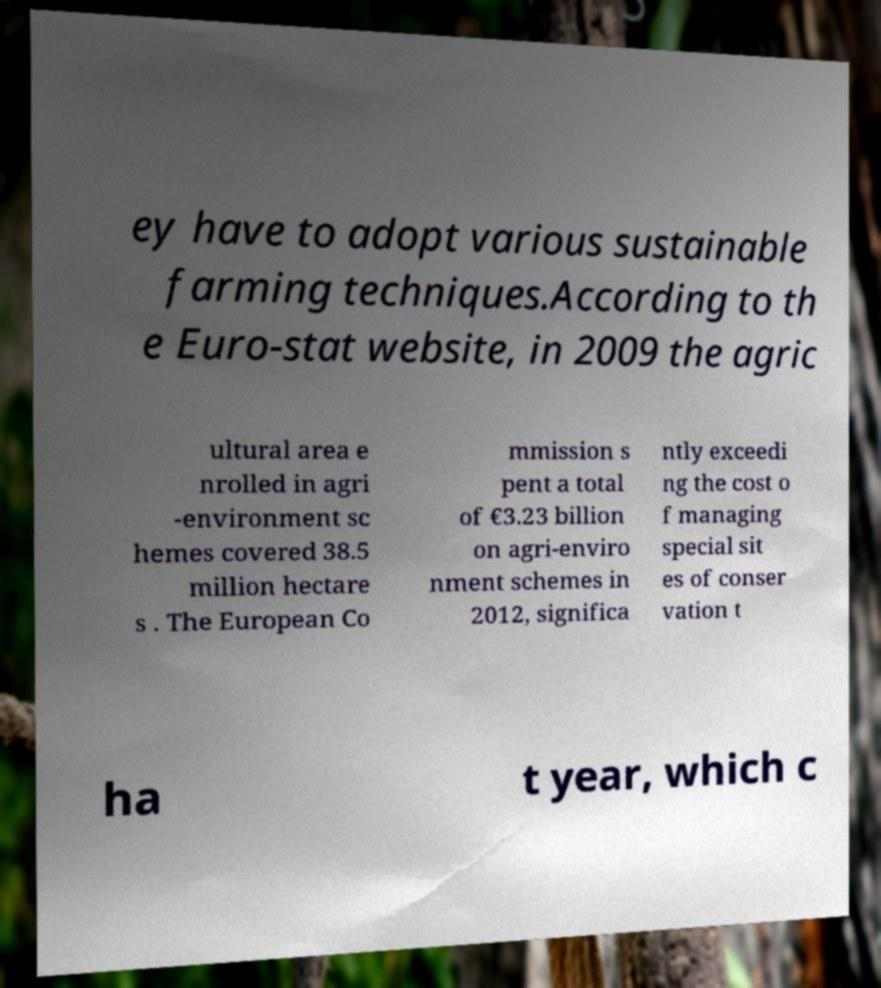Can you read and provide the text displayed in the image?This photo seems to have some interesting text. Can you extract and type it out for me? ey have to adopt various sustainable farming techniques.According to th e Euro-stat website, in 2009 the agric ultural area e nrolled in agri -environment sc hemes covered 38.5 million hectare s . The European Co mmission s pent a total of €3.23 billion on agri-enviro nment schemes in 2012, significa ntly exceedi ng the cost o f managing special sit es of conser vation t ha t year, which c 